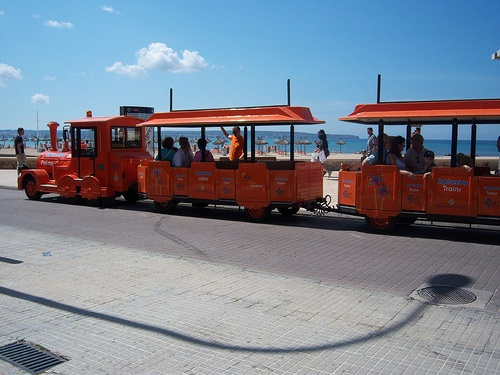Describe the objects in this image and their specific colors. I can see train in lightblue, maroon, black, brown, and gray tones, people in lightblue, maroon, black, red, and gray tones, people in lightblue, black, maroon, and brown tones, people in lightblue, black, purple, and darkblue tones, and people in lightblue, black, and gray tones in this image. 